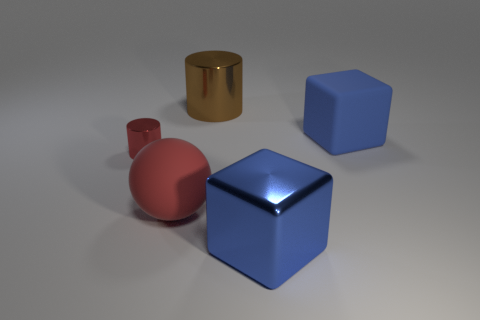What number of green things are either small objects or big cylinders?
Your answer should be very brief. 0. Are there any other things of the same color as the tiny cylinder?
Your answer should be very brief. Yes. What is the color of the matte thing behind the metal object that is on the left side of the brown object?
Give a very brief answer. Blue. Is the number of red shiny cylinders that are behind the tiny red cylinder less than the number of brown objects that are on the right side of the blue metal thing?
Keep it short and to the point. No. There is a big object that is the same color as the metallic cube; what is its material?
Provide a succinct answer. Rubber. How many objects are either blue cubes right of the metallic block or metal cubes?
Provide a succinct answer. 2. Does the cylinder that is to the left of the red rubber object have the same size as the large blue shiny block?
Ensure brevity in your answer.  No. Is the number of blocks that are behind the large red rubber object less than the number of large blue rubber blocks?
Give a very brief answer. No. What is the material of the brown cylinder that is the same size as the red sphere?
Ensure brevity in your answer.  Metal. How many tiny things are purple things or cubes?
Your answer should be very brief. 0. 